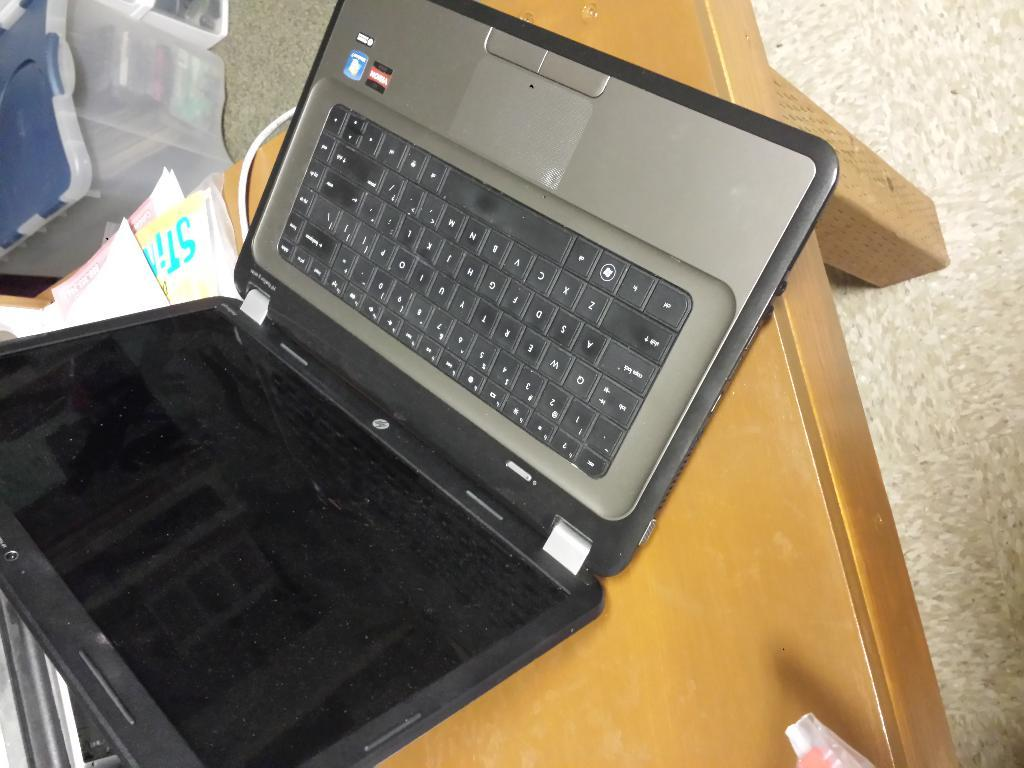What electronic device is on the table in the image? There is a laptop on the table in the image. What else can be seen on the table besides the laptop? There are objects on the table in the image. What is located on the floor in the image? There is a box on the floor in the image. What type of pocket can be seen on the laptop in the image? There is no pocket visible on the laptop in the image. 